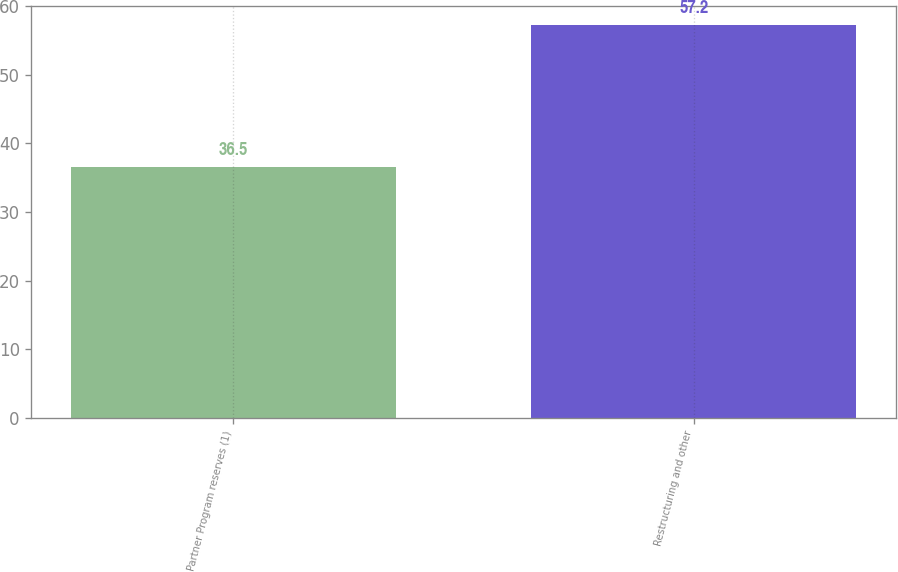Convert chart. <chart><loc_0><loc_0><loc_500><loc_500><bar_chart><fcel>Partner Program reserves (1)<fcel>Restructuring and other<nl><fcel>36.5<fcel>57.2<nl></chart> 